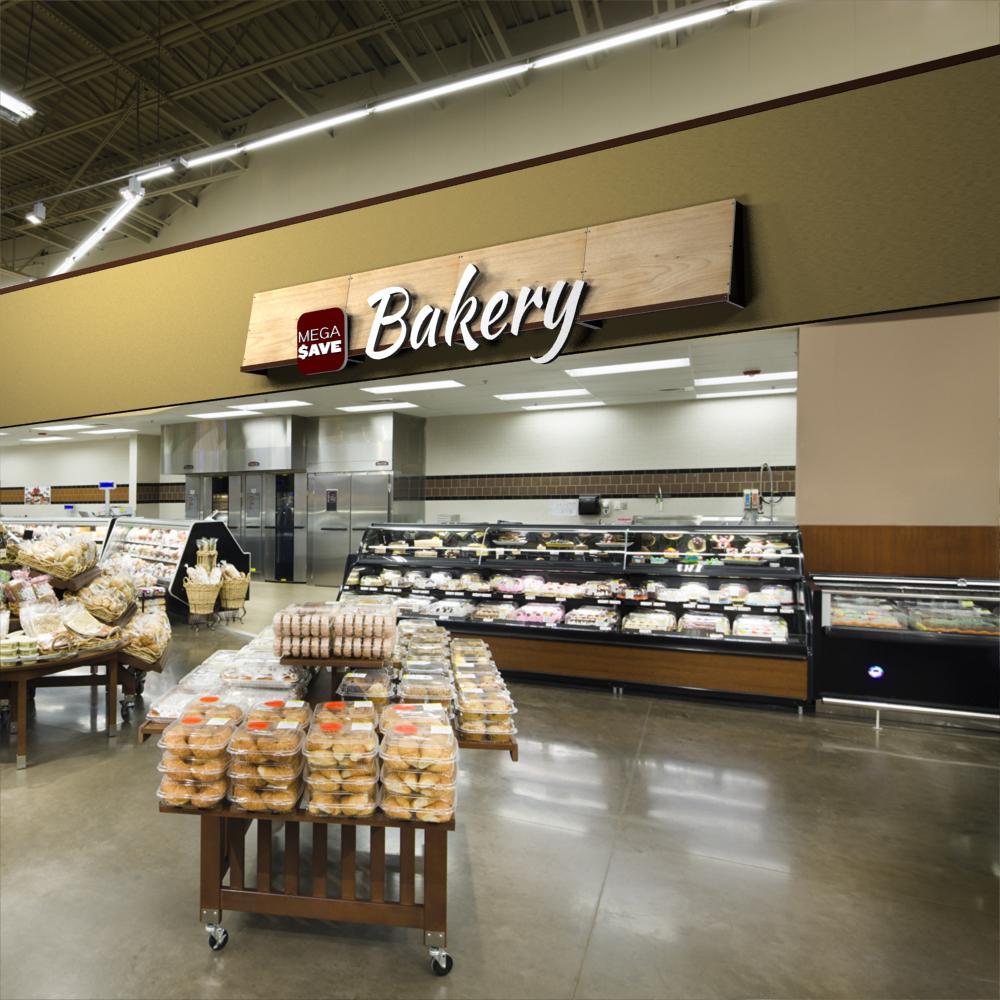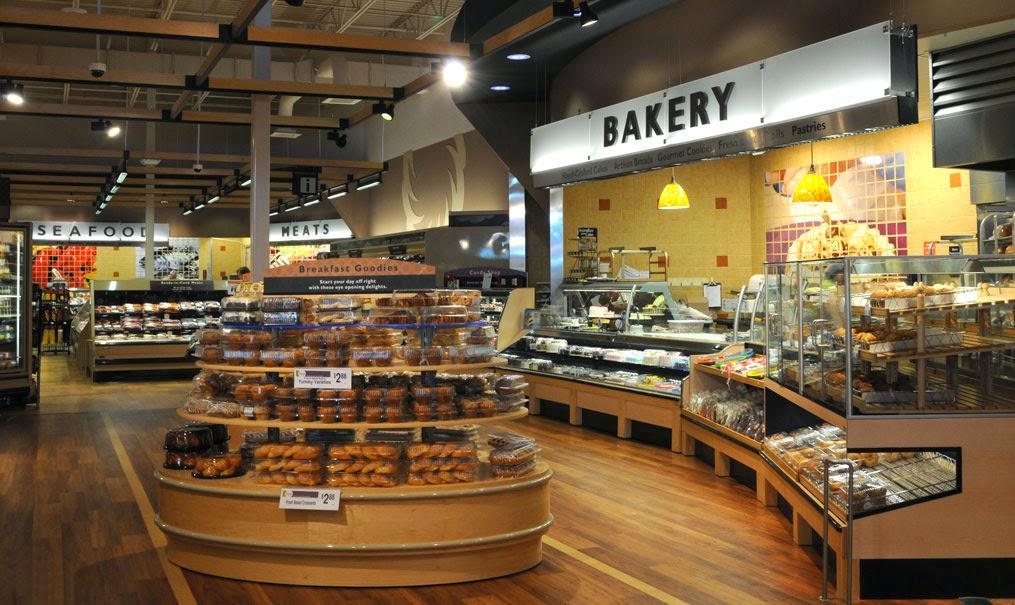The first image is the image on the left, the second image is the image on the right. Assess this claim about the two images: "In at least one image you can see a dropped or lowered all white hood lamp near the bakery.". Correct or not? Answer yes or no. No. 